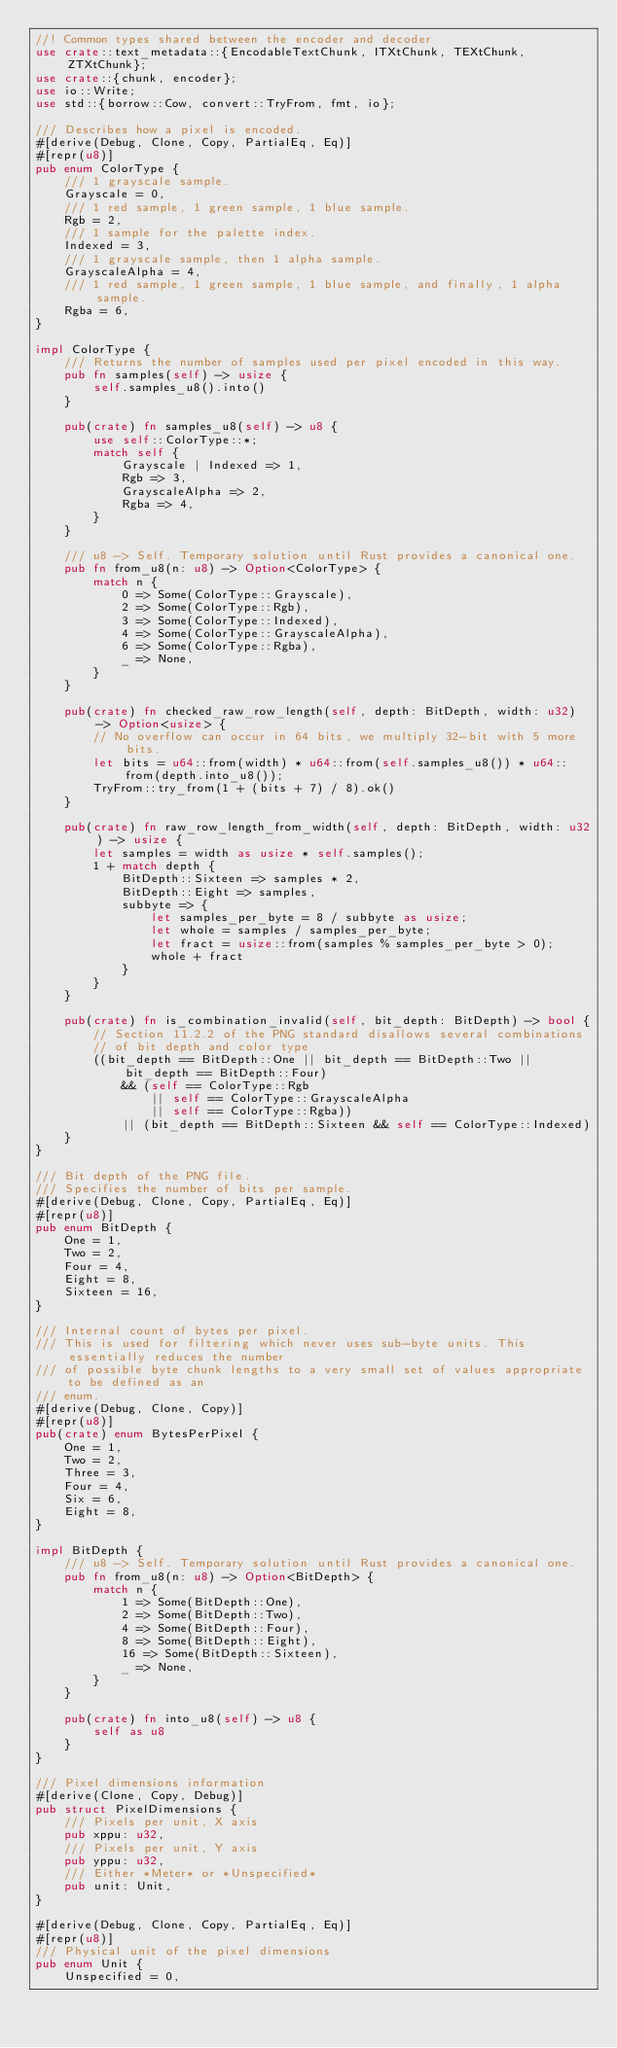<code> <loc_0><loc_0><loc_500><loc_500><_Rust_>//! Common types shared between the encoder and decoder
use crate::text_metadata::{EncodableTextChunk, ITXtChunk, TEXtChunk, ZTXtChunk};
use crate::{chunk, encoder};
use io::Write;
use std::{borrow::Cow, convert::TryFrom, fmt, io};

/// Describes how a pixel is encoded.
#[derive(Debug, Clone, Copy, PartialEq, Eq)]
#[repr(u8)]
pub enum ColorType {
    /// 1 grayscale sample.
    Grayscale = 0,
    /// 1 red sample, 1 green sample, 1 blue sample.
    Rgb = 2,
    /// 1 sample for the palette index.
    Indexed = 3,
    /// 1 grayscale sample, then 1 alpha sample.
    GrayscaleAlpha = 4,
    /// 1 red sample, 1 green sample, 1 blue sample, and finally, 1 alpha sample.
    Rgba = 6,
}

impl ColorType {
    /// Returns the number of samples used per pixel encoded in this way.
    pub fn samples(self) -> usize {
        self.samples_u8().into()
    }

    pub(crate) fn samples_u8(self) -> u8 {
        use self::ColorType::*;
        match self {
            Grayscale | Indexed => 1,
            Rgb => 3,
            GrayscaleAlpha => 2,
            Rgba => 4,
        }
    }

    /// u8 -> Self. Temporary solution until Rust provides a canonical one.
    pub fn from_u8(n: u8) -> Option<ColorType> {
        match n {
            0 => Some(ColorType::Grayscale),
            2 => Some(ColorType::Rgb),
            3 => Some(ColorType::Indexed),
            4 => Some(ColorType::GrayscaleAlpha),
            6 => Some(ColorType::Rgba),
            _ => None,
        }
    }

    pub(crate) fn checked_raw_row_length(self, depth: BitDepth, width: u32) -> Option<usize> {
        // No overflow can occur in 64 bits, we multiply 32-bit with 5 more bits.
        let bits = u64::from(width) * u64::from(self.samples_u8()) * u64::from(depth.into_u8());
        TryFrom::try_from(1 + (bits + 7) / 8).ok()
    }

    pub(crate) fn raw_row_length_from_width(self, depth: BitDepth, width: u32) -> usize {
        let samples = width as usize * self.samples();
        1 + match depth {
            BitDepth::Sixteen => samples * 2,
            BitDepth::Eight => samples,
            subbyte => {
                let samples_per_byte = 8 / subbyte as usize;
                let whole = samples / samples_per_byte;
                let fract = usize::from(samples % samples_per_byte > 0);
                whole + fract
            }
        }
    }

    pub(crate) fn is_combination_invalid(self, bit_depth: BitDepth) -> bool {
        // Section 11.2.2 of the PNG standard disallows several combinations
        // of bit depth and color type
        ((bit_depth == BitDepth::One || bit_depth == BitDepth::Two || bit_depth == BitDepth::Four)
            && (self == ColorType::Rgb
                || self == ColorType::GrayscaleAlpha
                || self == ColorType::Rgba))
            || (bit_depth == BitDepth::Sixteen && self == ColorType::Indexed)
    }
}

/// Bit depth of the PNG file.
/// Specifies the number of bits per sample.
#[derive(Debug, Clone, Copy, PartialEq, Eq)]
#[repr(u8)]
pub enum BitDepth {
    One = 1,
    Two = 2,
    Four = 4,
    Eight = 8,
    Sixteen = 16,
}

/// Internal count of bytes per pixel.
/// This is used for filtering which never uses sub-byte units. This essentially reduces the number
/// of possible byte chunk lengths to a very small set of values appropriate to be defined as an
/// enum.
#[derive(Debug, Clone, Copy)]
#[repr(u8)]
pub(crate) enum BytesPerPixel {
    One = 1,
    Two = 2,
    Three = 3,
    Four = 4,
    Six = 6,
    Eight = 8,
}

impl BitDepth {
    /// u8 -> Self. Temporary solution until Rust provides a canonical one.
    pub fn from_u8(n: u8) -> Option<BitDepth> {
        match n {
            1 => Some(BitDepth::One),
            2 => Some(BitDepth::Two),
            4 => Some(BitDepth::Four),
            8 => Some(BitDepth::Eight),
            16 => Some(BitDepth::Sixteen),
            _ => None,
        }
    }

    pub(crate) fn into_u8(self) -> u8 {
        self as u8
    }
}

/// Pixel dimensions information
#[derive(Clone, Copy, Debug)]
pub struct PixelDimensions {
    /// Pixels per unit, X axis
    pub xppu: u32,
    /// Pixels per unit, Y axis
    pub yppu: u32,
    /// Either *Meter* or *Unspecified*
    pub unit: Unit,
}

#[derive(Debug, Clone, Copy, PartialEq, Eq)]
#[repr(u8)]
/// Physical unit of the pixel dimensions
pub enum Unit {
    Unspecified = 0,</code> 